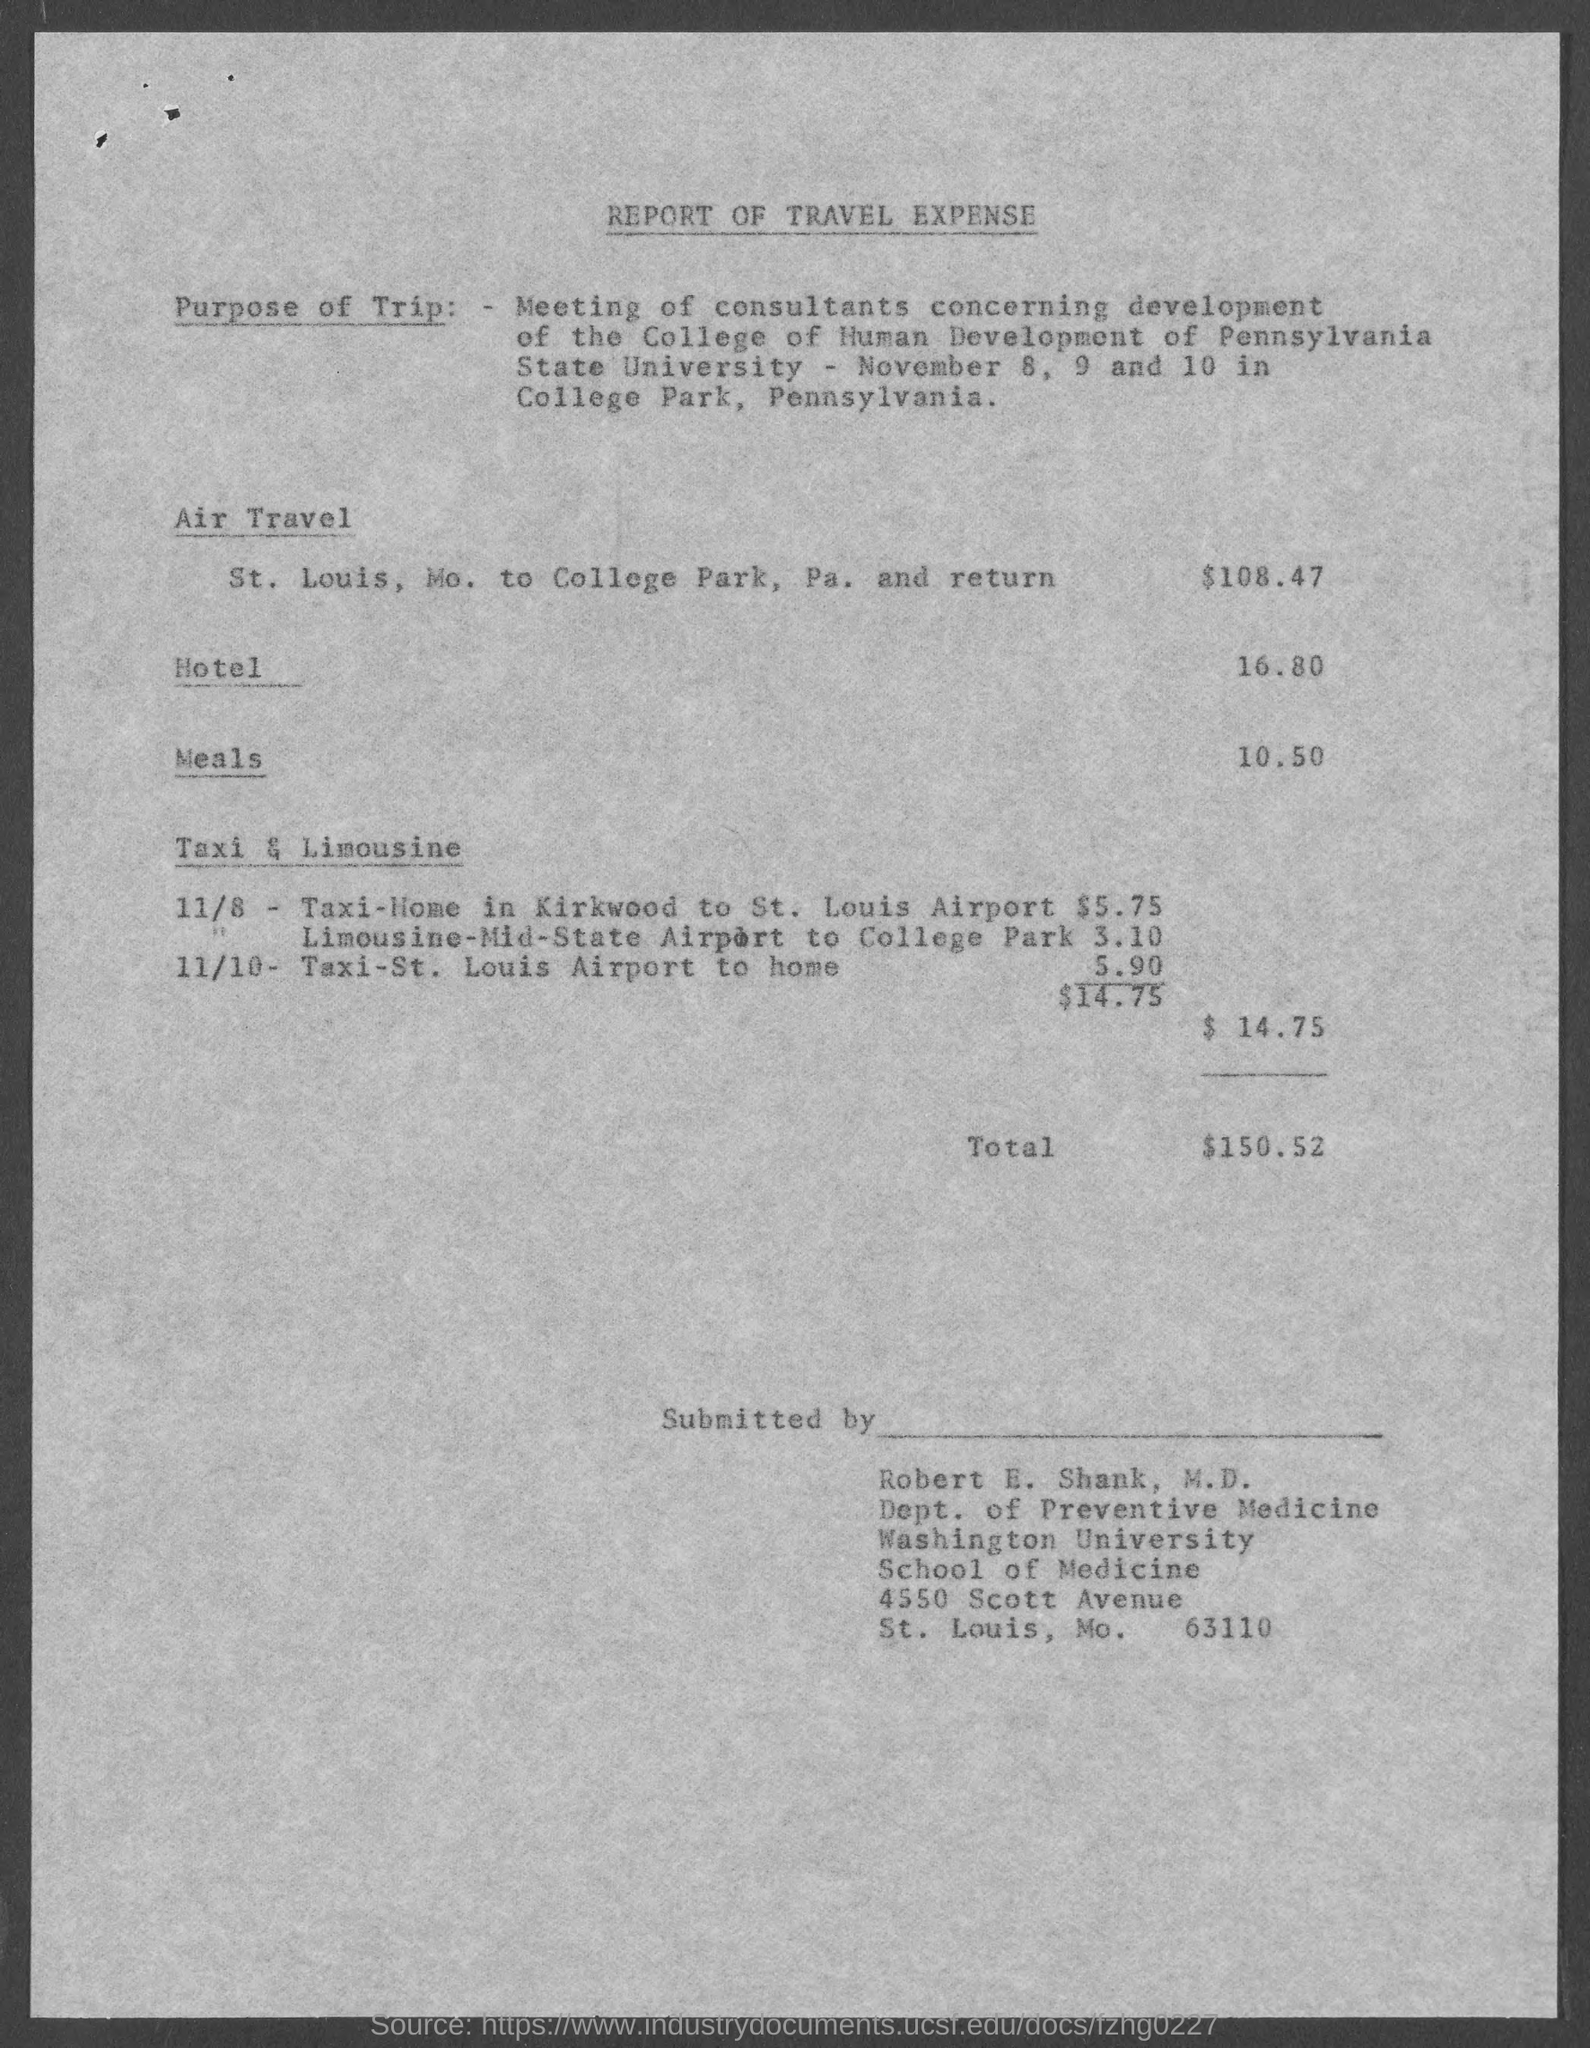What type of report is this?
Offer a very short reply. REPORT OF TRAVEL EXPENSE. What is the air travel expense given in the document?
Offer a very short reply. $108.47. What is the total travel expense mentioned in the document?
Ensure brevity in your answer.  150.52. Who has submitted this travel expense report?
Your answer should be compact. Robert E. Shank, M.D. When & where was the meeting of consultants held?
Make the answer very short. November 8, 9 and 10 in College Park, Pennsylvania. 